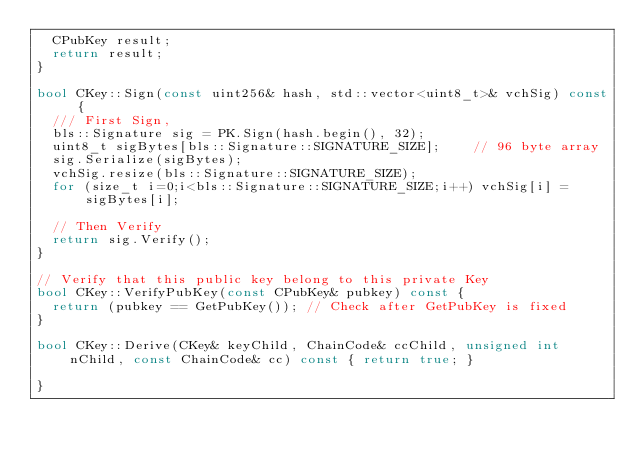Convert code to text. <code><loc_0><loc_0><loc_500><loc_500><_C++_>  CPubKey result;
  return result;
}

bool CKey::Sign(const uint256& hash, std::vector<uint8_t>& vchSig) const {
  /// First Sign,
  bls::Signature sig = PK.Sign(hash.begin(), 32);
  uint8_t sigBytes[bls::Signature::SIGNATURE_SIZE];    // 96 byte array
  sig.Serialize(sigBytes);
  vchSig.resize(bls::Signature::SIGNATURE_SIZE);
  for (size_t i=0;i<bls::Signature::SIGNATURE_SIZE;i++) vchSig[i] = sigBytes[i];
  
  // Then Verify
  return sig.Verify();
}

// Verify that this public key belong to this private Key
bool CKey::VerifyPubKey(const CPubKey& pubkey) const {
  return (pubkey == GetPubKey()); // Check after GetPubKey is fixed
}

bool CKey::Derive(CKey& keyChild, ChainCode& ccChild, unsigned int nChild, const ChainCode& cc) const { return true; }

}
</code> 